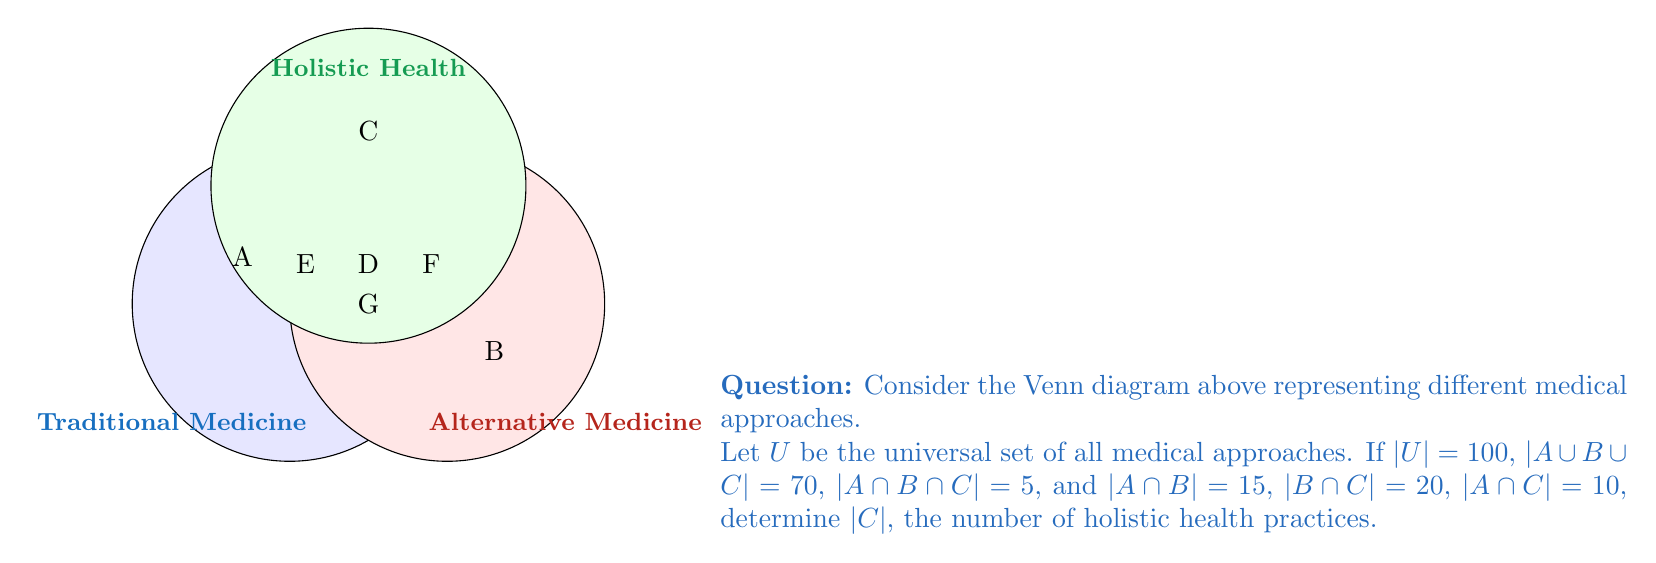Give your solution to this math problem. Let's approach this step-by-step:

1) First, we need to recall the inclusion-exclusion principle for three sets:

   $$|A \cup B \cup C| = |A| + |B| + |C| - |A \cap B| - |B \cap C| - |A \cap C| + |A \cap B \cap C|$$

2) We're given that $|A \cup B \cup C| = 70$, $|A \cap B \cap C| = 5$, $|A \cap B| = 15$, $|B \cap C| = 20$, and $|A \cap C| = 10$. Let's substitute these into our equation:

   $$70 = |A| + |B| + |C| - 15 - 20 - 10 + 5$$

3) Simplify:

   $$110 = |A| + |B| + |C|$$

4) Now, we need to find $|C|$. We can't solve this equation directly as we have three unknowns. However, we're only interested in $|C|$, which represents holistic health practices.

5) The region $C$ in the Venn diagram consists of:
   - The area unique to C
   - The area shared with A but not B: $|A \cap C| - |A \cap B \cap C|$
   - The area shared with B but not A: $|B \cap C| - |A \cap B \cap C|$
   - The area shared by all three: $|A \cap B \cap C|$

6) Therefore:

   $$|C| = (|C| - |A \cap C| - |B \cap C| + |A \cap B \cap C|) + (|A \cap C| - |A \cap B \cap C|) + (|B \cap C| - |A \cap B \cap C|) + |A \cap B \cap C|$$

7) Simplify:

   $$|C| = |C| - |A \cap C| - |B \cap C| + |A \cap B \cap C| + |A \cap C| - |A \cap B \cap C| + |B \cap C| - |A \cap B \cap C| + |A \cap B \cap C|$$
   $$|C| = |C|$$

8) This shows our logic is correct. Now let's substitute the known values:

   $$|C| = |C| - 10 - 20 + 5 + 10 + 20 - 5 + 5 = |C| + 5$$

9) Therefore, the unique part of C (holistic health practices that are neither traditional nor alternative) is 5.

10) The total number of holistic health practices is this unique part plus the intersections:

    $$|C| = 5 + 10 + 20 - 5 = 30$$

Thus, there are 30 holistic health practices in total.
Answer: $|C| = 30$ 